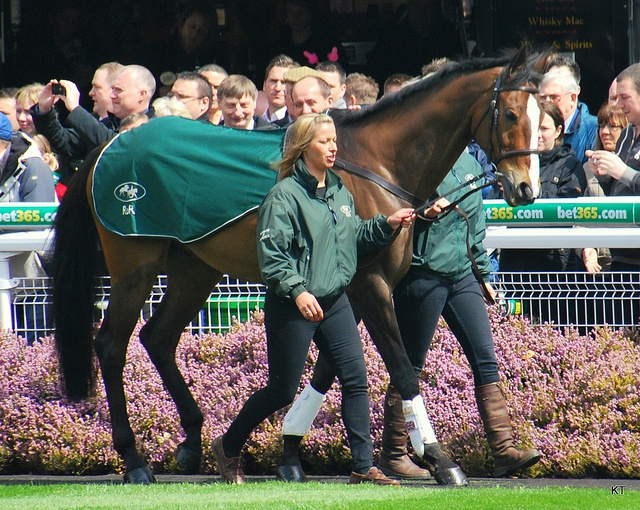Describe the objects in this image and their specific colors. I can see horse in black, gray, and maroon tones, people in black, gray, teal, and darkgray tones, people in black, gray, ivory, and darkgray tones, people in black, gray, and teal tones, and people in black, lightgray, gray, and tan tones in this image. 